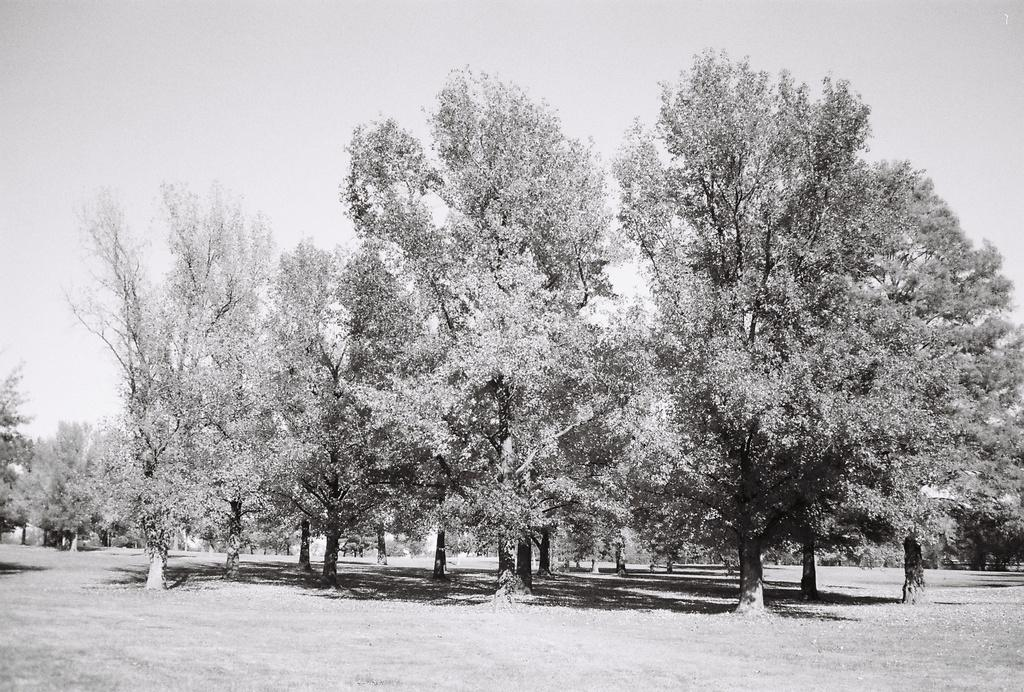What is the color scheme of the image? The image is black and white. What type of terrain is visible at the bottom of the image? There is ground visible at the bottom of the image. What can be seen in the middle of the image? There are many trees in the middle of the image. What is visible at the top of the image? The sky is visible at the top of the image. What type of kite is being flown in the image? There is no kite present in the image, so it is not possible to determine the type of kite being flown. 